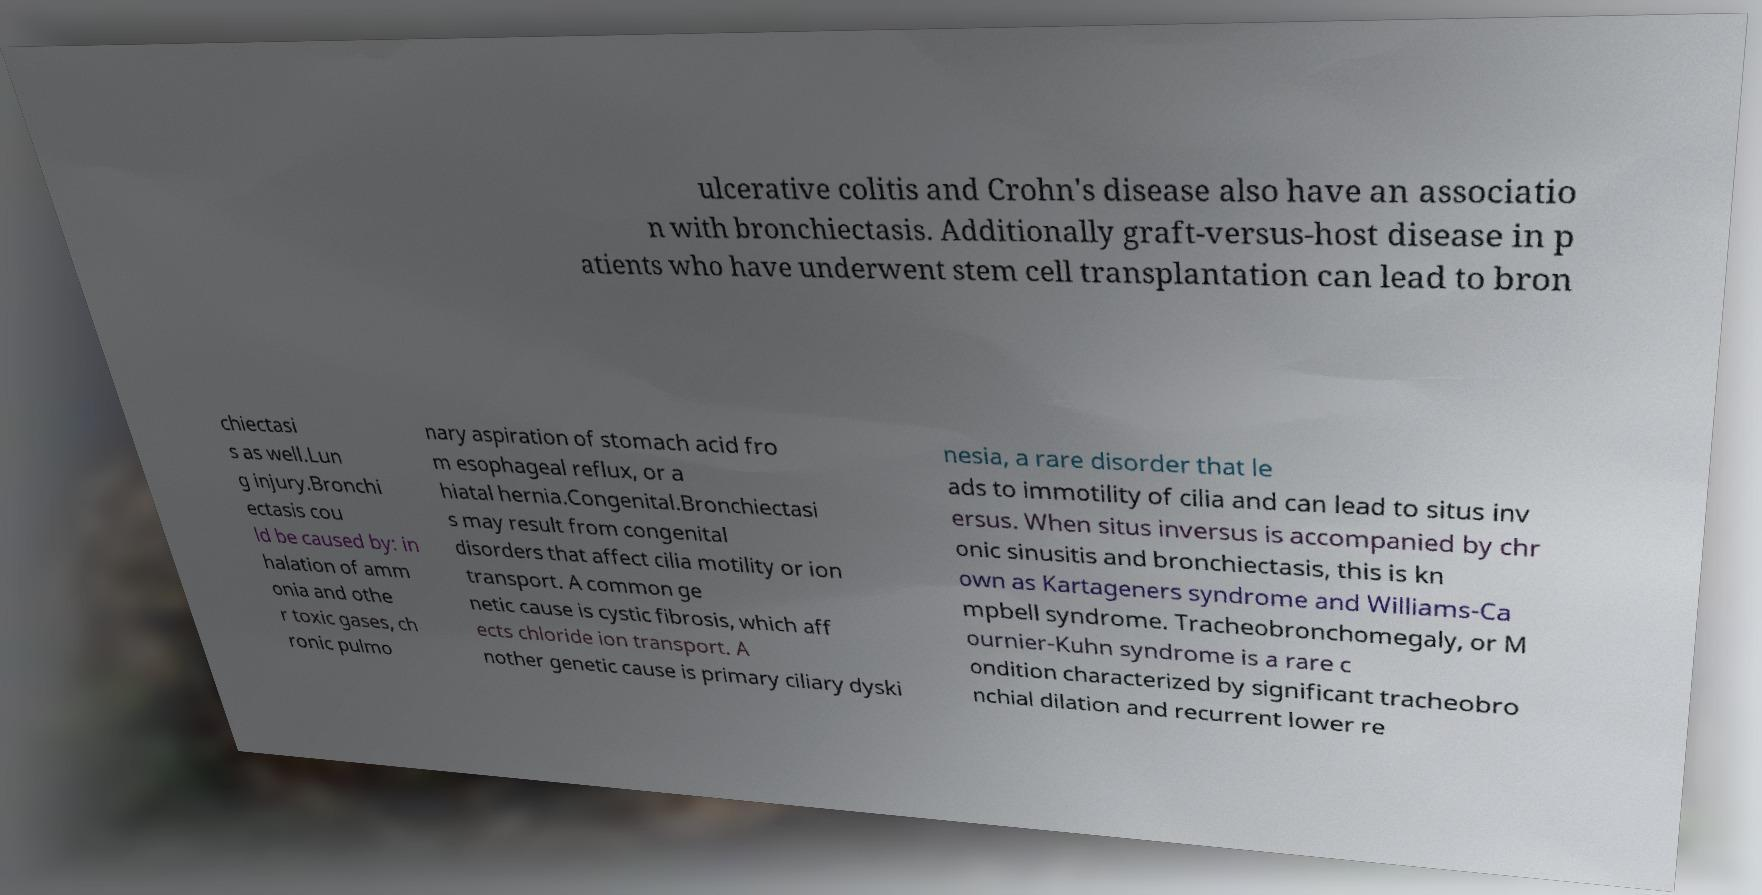Could you assist in decoding the text presented in this image and type it out clearly? ulcerative colitis and Crohn's disease also have an associatio n with bronchiectasis. Additionally graft-versus-host disease in p atients who have underwent stem cell transplantation can lead to bron chiectasi s as well.Lun g injury.Bronchi ectasis cou ld be caused by: in halation of amm onia and othe r toxic gases, ch ronic pulmo nary aspiration of stomach acid fro m esophageal reflux, or a hiatal hernia.Congenital.Bronchiectasi s may result from congenital disorders that affect cilia motility or ion transport. A common ge netic cause is cystic fibrosis, which aff ects chloride ion transport. A nother genetic cause is primary ciliary dyski nesia, a rare disorder that le ads to immotility of cilia and can lead to situs inv ersus. When situs inversus is accompanied by chr onic sinusitis and bronchiectasis, this is kn own as Kartageners syndrome and Williams-Ca mpbell syndrome. Tracheobronchomegaly, or M ournier-Kuhn syndrome is a rare c ondition characterized by significant tracheobro nchial dilation and recurrent lower re 